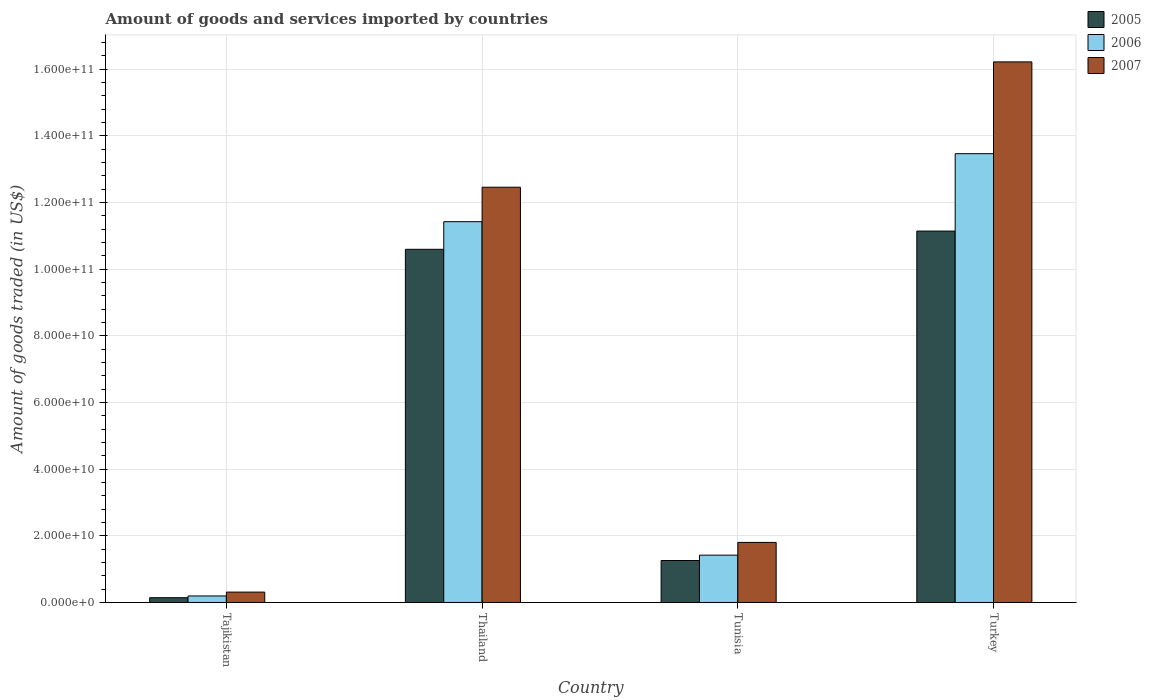How many different coloured bars are there?
Provide a succinct answer. 3. How many groups of bars are there?
Provide a succinct answer. 4. Are the number of bars on each tick of the X-axis equal?
Make the answer very short. Yes. How many bars are there on the 2nd tick from the left?
Provide a short and direct response. 3. How many bars are there on the 3rd tick from the right?
Your response must be concise. 3. What is the label of the 2nd group of bars from the left?
Provide a succinct answer. Thailand. What is the total amount of goods and services imported in 2006 in Turkey?
Provide a short and direct response. 1.35e+11. Across all countries, what is the maximum total amount of goods and services imported in 2007?
Provide a short and direct response. 1.62e+11. Across all countries, what is the minimum total amount of goods and services imported in 2005?
Offer a terse response. 1.43e+09. In which country was the total amount of goods and services imported in 2007 minimum?
Your answer should be compact. Tajikistan. What is the total total amount of goods and services imported in 2005 in the graph?
Make the answer very short. 2.31e+11. What is the difference between the total amount of goods and services imported in 2006 in Thailand and that in Tunisia?
Offer a very short reply. 1.00e+11. What is the difference between the total amount of goods and services imported in 2005 in Tajikistan and the total amount of goods and services imported in 2006 in Turkey?
Make the answer very short. -1.33e+11. What is the average total amount of goods and services imported in 2007 per country?
Give a very brief answer. 7.70e+1. What is the difference between the total amount of goods and services imported of/in 2006 and total amount of goods and services imported of/in 2005 in Turkey?
Provide a short and direct response. 2.32e+1. In how many countries, is the total amount of goods and services imported in 2006 greater than 144000000000 US$?
Provide a short and direct response. 0. What is the ratio of the total amount of goods and services imported in 2005 in Tajikistan to that in Tunisia?
Ensure brevity in your answer.  0.11. Is the total amount of goods and services imported in 2007 in Tajikistan less than that in Thailand?
Ensure brevity in your answer.  Yes. Is the difference between the total amount of goods and services imported in 2006 in Thailand and Turkey greater than the difference between the total amount of goods and services imported in 2005 in Thailand and Turkey?
Your response must be concise. No. What is the difference between the highest and the second highest total amount of goods and services imported in 2006?
Your answer should be compact. 1.20e+11. What is the difference between the highest and the lowest total amount of goods and services imported in 2006?
Give a very brief answer. 1.33e+11. Is the sum of the total amount of goods and services imported in 2006 in Thailand and Turkey greater than the maximum total amount of goods and services imported in 2007 across all countries?
Provide a short and direct response. Yes. What does the 1st bar from the left in Turkey represents?
Your answer should be compact. 2005. What does the 2nd bar from the right in Turkey represents?
Offer a very short reply. 2006. How many bars are there?
Keep it short and to the point. 12. Are all the bars in the graph horizontal?
Keep it short and to the point. No. What is the difference between two consecutive major ticks on the Y-axis?
Your answer should be compact. 2.00e+1. Are the values on the major ticks of Y-axis written in scientific E-notation?
Your answer should be compact. Yes. Does the graph contain grids?
Ensure brevity in your answer.  Yes. How many legend labels are there?
Your response must be concise. 3. What is the title of the graph?
Give a very brief answer. Amount of goods and services imported by countries. What is the label or title of the Y-axis?
Offer a very short reply. Amount of goods traded (in US$). What is the Amount of goods traded (in US$) of 2005 in Tajikistan?
Ensure brevity in your answer.  1.43e+09. What is the Amount of goods traded (in US$) in 2006 in Tajikistan?
Your answer should be compact. 1.95e+09. What is the Amount of goods traded (in US$) of 2007 in Tajikistan?
Your answer should be very brief. 3.12e+09. What is the Amount of goods traded (in US$) in 2005 in Thailand?
Provide a succinct answer. 1.06e+11. What is the Amount of goods traded (in US$) in 2006 in Thailand?
Keep it short and to the point. 1.14e+11. What is the Amount of goods traded (in US$) in 2007 in Thailand?
Keep it short and to the point. 1.25e+11. What is the Amount of goods traded (in US$) in 2005 in Tunisia?
Give a very brief answer. 1.26e+1. What is the Amount of goods traded (in US$) in 2006 in Tunisia?
Your answer should be very brief. 1.42e+1. What is the Amount of goods traded (in US$) of 2007 in Tunisia?
Your response must be concise. 1.80e+1. What is the Amount of goods traded (in US$) in 2005 in Turkey?
Provide a short and direct response. 1.11e+11. What is the Amount of goods traded (in US$) in 2006 in Turkey?
Provide a short and direct response. 1.35e+11. What is the Amount of goods traded (in US$) of 2007 in Turkey?
Offer a very short reply. 1.62e+11. Across all countries, what is the maximum Amount of goods traded (in US$) in 2005?
Provide a short and direct response. 1.11e+11. Across all countries, what is the maximum Amount of goods traded (in US$) in 2006?
Your response must be concise. 1.35e+11. Across all countries, what is the maximum Amount of goods traded (in US$) of 2007?
Make the answer very short. 1.62e+11. Across all countries, what is the minimum Amount of goods traded (in US$) in 2005?
Ensure brevity in your answer.  1.43e+09. Across all countries, what is the minimum Amount of goods traded (in US$) in 2006?
Your answer should be very brief. 1.95e+09. Across all countries, what is the minimum Amount of goods traded (in US$) in 2007?
Your answer should be compact. 3.12e+09. What is the total Amount of goods traded (in US$) in 2005 in the graph?
Keep it short and to the point. 2.31e+11. What is the total Amount of goods traded (in US$) in 2006 in the graph?
Your answer should be compact. 2.65e+11. What is the total Amount of goods traded (in US$) in 2007 in the graph?
Your response must be concise. 3.08e+11. What is the difference between the Amount of goods traded (in US$) of 2005 in Tajikistan and that in Thailand?
Your answer should be compact. -1.05e+11. What is the difference between the Amount of goods traded (in US$) of 2006 in Tajikistan and that in Thailand?
Ensure brevity in your answer.  -1.12e+11. What is the difference between the Amount of goods traded (in US$) in 2007 in Tajikistan and that in Thailand?
Make the answer very short. -1.21e+11. What is the difference between the Amount of goods traded (in US$) of 2005 in Tajikistan and that in Tunisia?
Provide a succinct answer. -1.12e+1. What is the difference between the Amount of goods traded (in US$) in 2006 in Tajikistan and that in Tunisia?
Offer a terse response. -1.22e+1. What is the difference between the Amount of goods traded (in US$) of 2007 in Tajikistan and that in Tunisia?
Give a very brief answer. -1.49e+1. What is the difference between the Amount of goods traded (in US$) of 2005 in Tajikistan and that in Turkey?
Offer a terse response. -1.10e+11. What is the difference between the Amount of goods traded (in US$) of 2006 in Tajikistan and that in Turkey?
Make the answer very short. -1.33e+11. What is the difference between the Amount of goods traded (in US$) in 2007 in Tajikistan and that in Turkey?
Offer a very short reply. -1.59e+11. What is the difference between the Amount of goods traded (in US$) in 2005 in Thailand and that in Tunisia?
Make the answer very short. 9.34e+1. What is the difference between the Amount of goods traded (in US$) in 2006 in Thailand and that in Tunisia?
Ensure brevity in your answer.  1.00e+11. What is the difference between the Amount of goods traded (in US$) in 2007 in Thailand and that in Tunisia?
Your answer should be very brief. 1.07e+11. What is the difference between the Amount of goods traded (in US$) of 2005 in Thailand and that in Turkey?
Ensure brevity in your answer.  -5.47e+09. What is the difference between the Amount of goods traded (in US$) of 2006 in Thailand and that in Turkey?
Your answer should be compact. -2.04e+1. What is the difference between the Amount of goods traded (in US$) of 2007 in Thailand and that in Turkey?
Provide a short and direct response. -3.76e+1. What is the difference between the Amount of goods traded (in US$) in 2005 in Tunisia and that in Turkey?
Your answer should be compact. -9.89e+1. What is the difference between the Amount of goods traded (in US$) in 2006 in Tunisia and that in Turkey?
Give a very brief answer. -1.20e+11. What is the difference between the Amount of goods traded (in US$) in 2007 in Tunisia and that in Turkey?
Your response must be concise. -1.44e+11. What is the difference between the Amount of goods traded (in US$) in 2005 in Tajikistan and the Amount of goods traded (in US$) in 2006 in Thailand?
Provide a succinct answer. -1.13e+11. What is the difference between the Amount of goods traded (in US$) in 2005 in Tajikistan and the Amount of goods traded (in US$) in 2007 in Thailand?
Make the answer very short. -1.23e+11. What is the difference between the Amount of goods traded (in US$) of 2006 in Tajikistan and the Amount of goods traded (in US$) of 2007 in Thailand?
Your response must be concise. -1.23e+11. What is the difference between the Amount of goods traded (in US$) in 2005 in Tajikistan and the Amount of goods traded (in US$) in 2006 in Tunisia?
Provide a short and direct response. -1.28e+1. What is the difference between the Amount of goods traded (in US$) of 2005 in Tajikistan and the Amount of goods traded (in US$) of 2007 in Tunisia?
Your answer should be compact. -1.66e+1. What is the difference between the Amount of goods traded (in US$) of 2006 in Tajikistan and the Amount of goods traded (in US$) of 2007 in Tunisia?
Provide a short and direct response. -1.61e+1. What is the difference between the Amount of goods traded (in US$) in 2005 in Tajikistan and the Amount of goods traded (in US$) in 2006 in Turkey?
Your answer should be very brief. -1.33e+11. What is the difference between the Amount of goods traded (in US$) in 2005 in Tajikistan and the Amount of goods traded (in US$) in 2007 in Turkey?
Your answer should be very brief. -1.61e+11. What is the difference between the Amount of goods traded (in US$) in 2006 in Tajikistan and the Amount of goods traded (in US$) in 2007 in Turkey?
Offer a very short reply. -1.60e+11. What is the difference between the Amount of goods traded (in US$) in 2005 in Thailand and the Amount of goods traded (in US$) in 2006 in Tunisia?
Keep it short and to the point. 9.18e+1. What is the difference between the Amount of goods traded (in US$) in 2005 in Thailand and the Amount of goods traded (in US$) in 2007 in Tunisia?
Ensure brevity in your answer.  8.80e+1. What is the difference between the Amount of goods traded (in US$) of 2006 in Thailand and the Amount of goods traded (in US$) of 2007 in Tunisia?
Your response must be concise. 9.62e+1. What is the difference between the Amount of goods traded (in US$) in 2005 in Thailand and the Amount of goods traded (in US$) in 2006 in Turkey?
Give a very brief answer. -2.87e+1. What is the difference between the Amount of goods traded (in US$) in 2005 in Thailand and the Amount of goods traded (in US$) in 2007 in Turkey?
Your response must be concise. -5.62e+1. What is the difference between the Amount of goods traded (in US$) in 2006 in Thailand and the Amount of goods traded (in US$) in 2007 in Turkey?
Provide a succinct answer. -4.79e+1. What is the difference between the Amount of goods traded (in US$) of 2005 in Tunisia and the Amount of goods traded (in US$) of 2006 in Turkey?
Offer a terse response. -1.22e+11. What is the difference between the Amount of goods traded (in US$) in 2005 in Tunisia and the Amount of goods traded (in US$) in 2007 in Turkey?
Offer a very short reply. -1.50e+11. What is the difference between the Amount of goods traded (in US$) of 2006 in Tunisia and the Amount of goods traded (in US$) of 2007 in Turkey?
Provide a succinct answer. -1.48e+11. What is the average Amount of goods traded (in US$) in 2005 per country?
Keep it short and to the point. 5.79e+1. What is the average Amount of goods traded (in US$) of 2006 per country?
Keep it short and to the point. 6.63e+1. What is the average Amount of goods traded (in US$) of 2007 per country?
Offer a very short reply. 7.70e+1. What is the difference between the Amount of goods traded (in US$) of 2005 and Amount of goods traded (in US$) of 2006 in Tajikistan?
Provide a short and direct response. -5.24e+08. What is the difference between the Amount of goods traded (in US$) in 2005 and Amount of goods traded (in US$) in 2007 in Tajikistan?
Give a very brief answer. -1.68e+09. What is the difference between the Amount of goods traded (in US$) in 2006 and Amount of goods traded (in US$) in 2007 in Tajikistan?
Ensure brevity in your answer.  -1.16e+09. What is the difference between the Amount of goods traded (in US$) of 2005 and Amount of goods traded (in US$) of 2006 in Thailand?
Offer a very short reply. -8.29e+09. What is the difference between the Amount of goods traded (in US$) in 2005 and Amount of goods traded (in US$) in 2007 in Thailand?
Provide a succinct answer. -1.86e+1. What is the difference between the Amount of goods traded (in US$) of 2006 and Amount of goods traded (in US$) of 2007 in Thailand?
Provide a succinct answer. -1.03e+1. What is the difference between the Amount of goods traded (in US$) in 2005 and Amount of goods traded (in US$) in 2006 in Tunisia?
Your answer should be very brief. -1.61e+09. What is the difference between the Amount of goods traded (in US$) of 2005 and Amount of goods traded (in US$) of 2007 in Tunisia?
Keep it short and to the point. -5.43e+09. What is the difference between the Amount of goods traded (in US$) of 2006 and Amount of goods traded (in US$) of 2007 in Tunisia?
Make the answer very short. -3.82e+09. What is the difference between the Amount of goods traded (in US$) in 2005 and Amount of goods traded (in US$) in 2006 in Turkey?
Ensure brevity in your answer.  -2.32e+1. What is the difference between the Amount of goods traded (in US$) of 2005 and Amount of goods traded (in US$) of 2007 in Turkey?
Offer a terse response. -5.08e+1. What is the difference between the Amount of goods traded (in US$) of 2006 and Amount of goods traded (in US$) of 2007 in Turkey?
Your response must be concise. -2.75e+1. What is the ratio of the Amount of goods traded (in US$) in 2005 in Tajikistan to that in Thailand?
Ensure brevity in your answer.  0.01. What is the ratio of the Amount of goods traded (in US$) in 2006 in Tajikistan to that in Thailand?
Give a very brief answer. 0.02. What is the ratio of the Amount of goods traded (in US$) in 2007 in Tajikistan to that in Thailand?
Offer a terse response. 0.03. What is the ratio of the Amount of goods traded (in US$) in 2005 in Tajikistan to that in Tunisia?
Provide a succinct answer. 0.11. What is the ratio of the Amount of goods traded (in US$) of 2006 in Tajikistan to that in Tunisia?
Give a very brief answer. 0.14. What is the ratio of the Amount of goods traded (in US$) in 2007 in Tajikistan to that in Tunisia?
Keep it short and to the point. 0.17. What is the ratio of the Amount of goods traded (in US$) of 2005 in Tajikistan to that in Turkey?
Your answer should be compact. 0.01. What is the ratio of the Amount of goods traded (in US$) in 2006 in Tajikistan to that in Turkey?
Your response must be concise. 0.01. What is the ratio of the Amount of goods traded (in US$) in 2007 in Tajikistan to that in Turkey?
Make the answer very short. 0.02. What is the ratio of the Amount of goods traded (in US$) of 2005 in Thailand to that in Tunisia?
Offer a terse response. 8.41. What is the ratio of the Amount of goods traded (in US$) in 2006 in Thailand to that in Tunisia?
Keep it short and to the point. 8.05. What is the ratio of the Amount of goods traded (in US$) of 2007 in Thailand to that in Tunisia?
Your answer should be very brief. 6.91. What is the ratio of the Amount of goods traded (in US$) in 2005 in Thailand to that in Turkey?
Your response must be concise. 0.95. What is the ratio of the Amount of goods traded (in US$) of 2006 in Thailand to that in Turkey?
Your answer should be very brief. 0.85. What is the ratio of the Amount of goods traded (in US$) of 2007 in Thailand to that in Turkey?
Your response must be concise. 0.77. What is the ratio of the Amount of goods traded (in US$) of 2005 in Tunisia to that in Turkey?
Keep it short and to the point. 0.11. What is the ratio of the Amount of goods traded (in US$) of 2006 in Tunisia to that in Turkey?
Make the answer very short. 0.11. What is the difference between the highest and the second highest Amount of goods traded (in US$) in 2005?
Give a very brief answer. 5.47e+09. What is the difference between the highest and the second highest Amount of goods traded (in US$) of 2006?
Your answer should be very brief. 2.04e+1. What is the difference between the highest and the second highest Amount of goods traded (in US$) in 2007?
Offer a very short reply. 3.76e+1. What is the difference between the highest and the lowest Amount of goods traded (in US$) in 2005?
Provide a short and direct response. 1.10e+11. What is the difference between the highest and the lowest Amount of goods traded (in US$) in 2006?
Offer a very short reply. 1.33e+11. What is the difference between the highest and the lowest Amount of goods traded (in US$) of 2007?
Make the answer very short. 1.59e+11. 